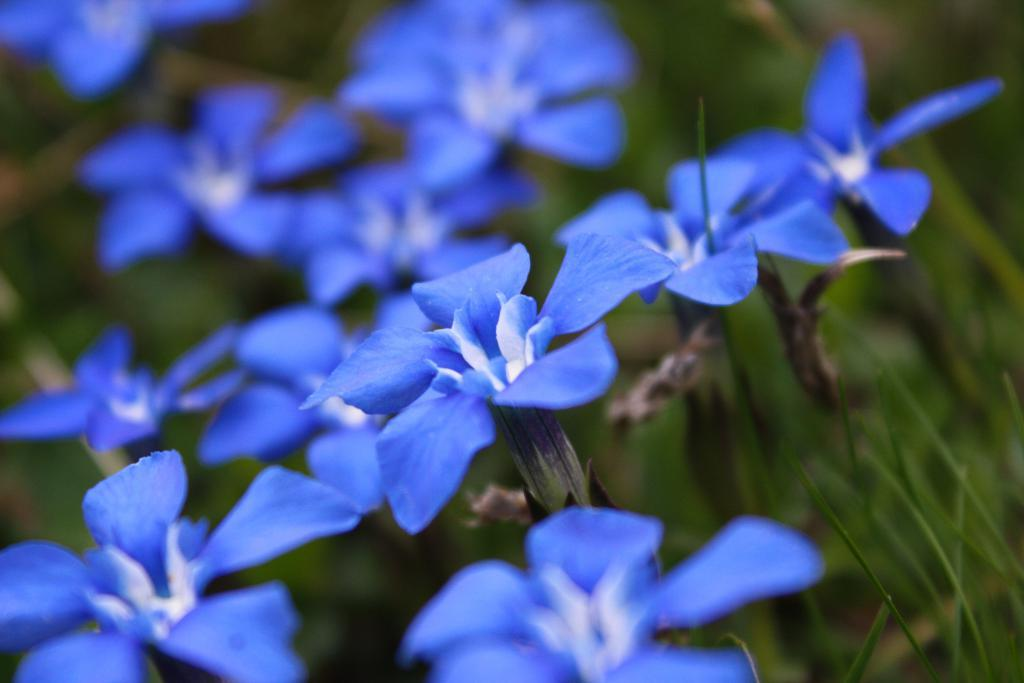What type of flowers can be seen in the image? There are purple colored flowers in the image. What else is present in the image besides the flowers? There are plants in the image. Can you describe the background of the image? The background of the image is blurred. What type of teeth does the zebra have in the image? There is no zebra present in the image, so it is not possible to determine what type of teeth it might have. 